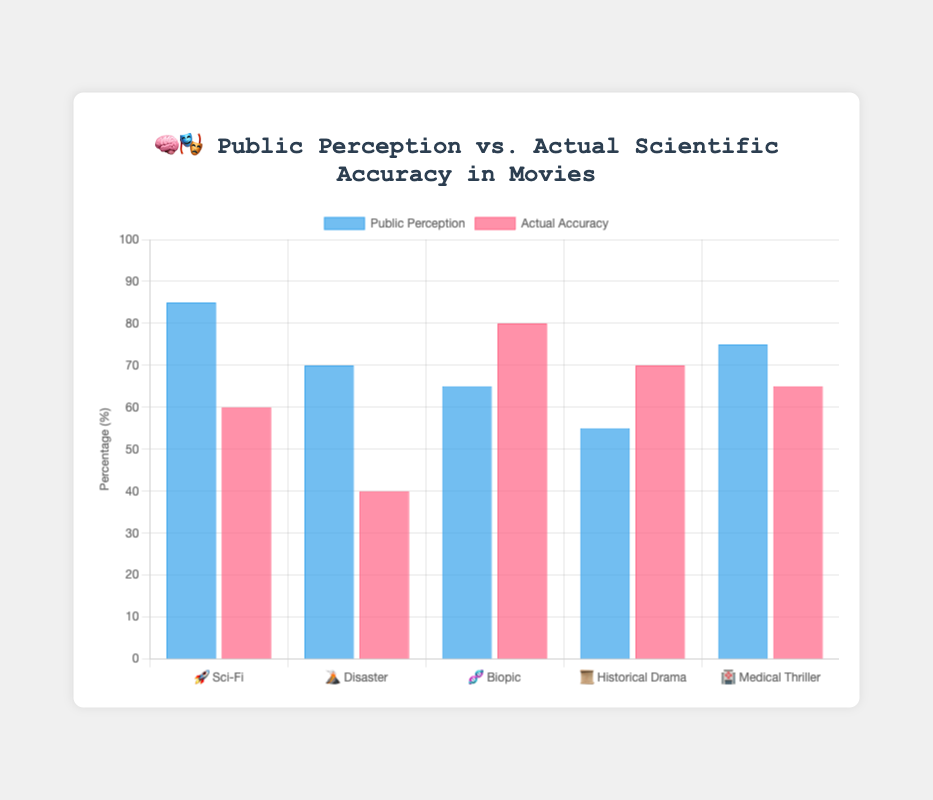What is the first genre listed in the chart? The first genre on the x-axis is "Sci-Fi" based on the genres ordered in the data.
Answer: Sci-Fi Which genre has the highest public perception of scientific credibility? By looking at the 'Public Perception' bars, "Sci-Fi" shows the highest value at 85%.
Answer: Sci-Fi What is the difference between public perception and actual accuracy for Disaster movies? The 'Public Perception' value for Disaster is 70%, and the 'Actual Accuracy' is 40%. The difference is 70 - 40.
Answer: 30 Which genre has a higher actual scientific accuracy than public perception? The 'Actual Accuracy' bars exceeding the 'Public Perception' bars are for "Biopic" where accuracy is 80% and perception is 65%.
Answer: Biopic What is the average public perception of all genres? Sum all 'Public Perception' values: (85 + 70 + 65 + 55 + 75) = 350. Divide by the number of genres, 350/5 gives the average.
Answer: 70 Comparing Sci-Fi and Medical Thriller, which genre has a closer alignment between public perception and actual accuracy? For Sci-Fi, the difference is 85 - 60 = 25. For Medical Thriller, it is 75 - 65 = 10. Medical Thriller has the smaller gap.
Answer: Medical Thriller Which genre has the largest gap between public perception and actual accuracy? Calculate differences for each genre; the largest is for Disaster with a gap of 30 (70 - 40).
Answer: Disaster What is the total actual scientific accuracy across all genres? Add all 'Actual Accuracy' values: (60 + 40 + 80 + 70 + 65) = 315.
Answer: 315 What percentage of genres have a public perception higher than their actual scientific accuracy? Compare 'Public Perception' and 'Actual Accuracy' for each genre: Sci-Fi, Disaster, and Medical Thriller have higher public perception, which is 3 out of 5 genres. To find the percentage, (3/5) * 100.
Answer: 60% Between Historical Drama and Medical Thriller, which has a higher actual scientific accuracy? 'Actual Accuracy' for Historical Drama is 70%, while for Medical Thriller it is 65%.
Answer: Historical Drama 